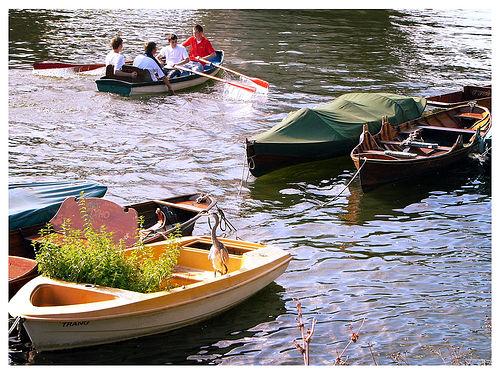How many boats are in use?
Write a very short answer. 1. How many of the boats are covered?
Concise answer only. 2. Are the boats parked near one another?
Keep it brief. Yes. 